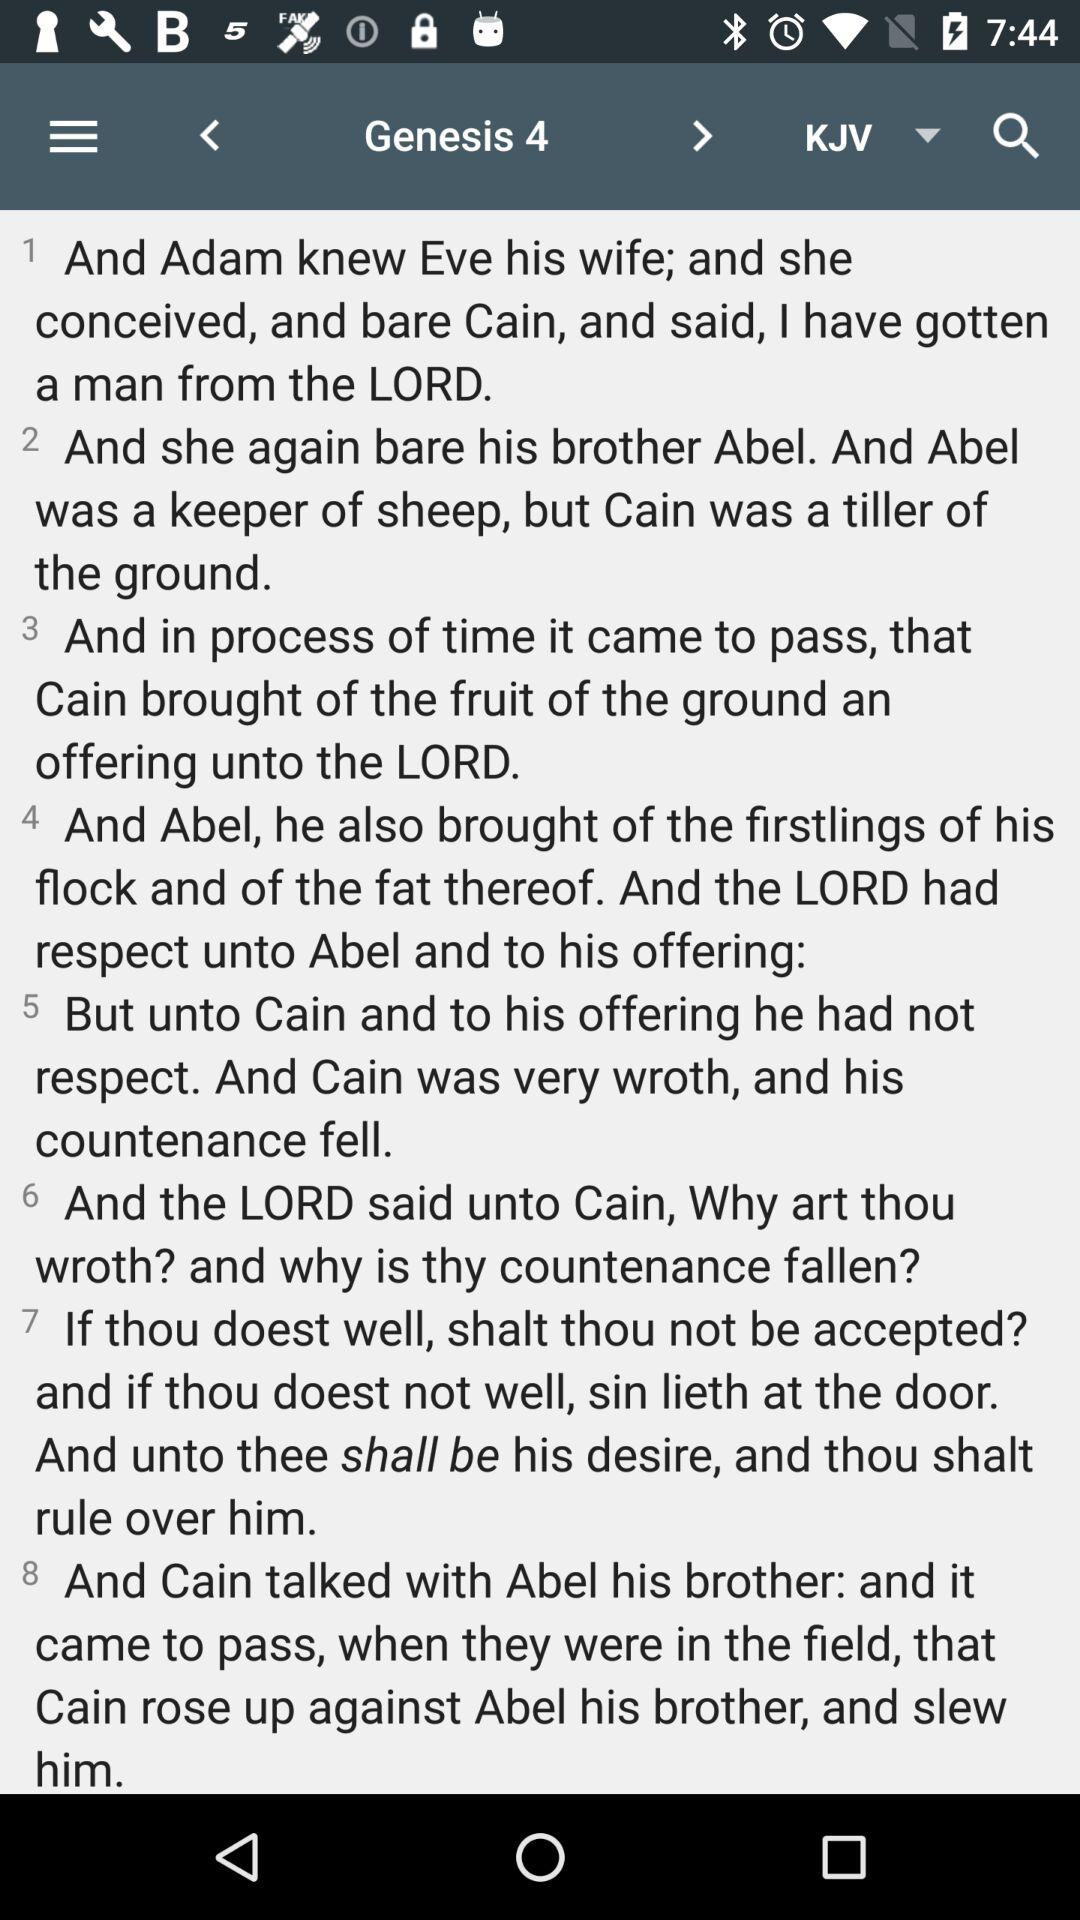How many verses are in the passage?
Answer the question using a single word or phrase. 8 